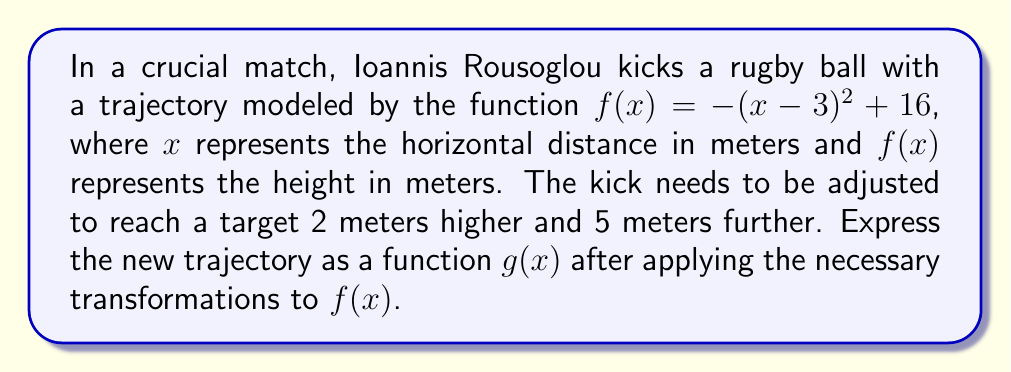Can you solve this math problem? To adjust the kick, we need to apply two transformations to $f(x)$:

1. Vertical shift up by 2 meters:
   This is represented by adding 2 to the function.
   $f_1(x) = f(x) + 2 = -(x-3)^2+16+2 = -(x-3)^2+18$

2. Horizontal shift right by 5 meters:
   This is represented by replacing $x$ with $(x-5)$ in the function.
   $g(x) = f_1(x-5) = -((x-5)-3)^2+18 = -(x-8)^2+18$

Therefore, the new trajectory function $g(x)$ is:

$$g(x) = -(x-8)^2+18$$

This function represents the parabola shifted 2 units up and 5 units right compared to the original function $f(x)$.
Answer: $g(x) = -(x-8)^2+18$ 